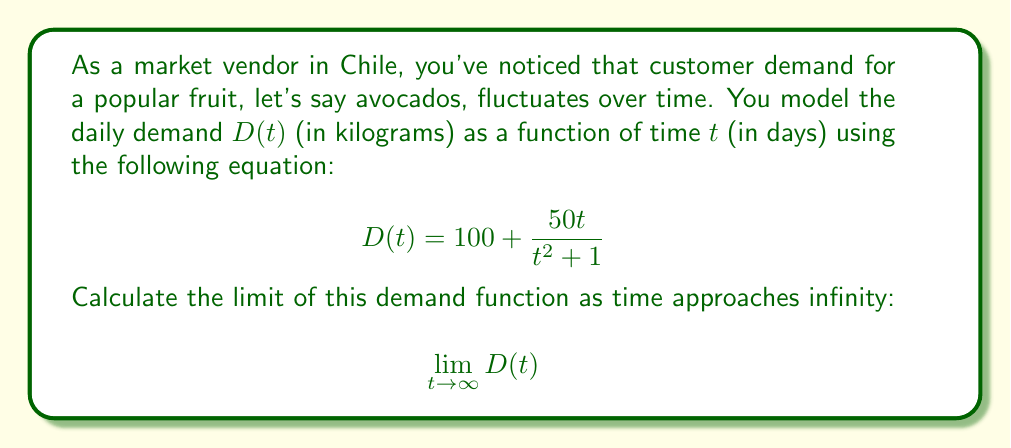Could you help me with this problem? To solve this problem, let's follow these steps:

1) First, let's recall the limit definition:
   $$\lim_{t \to \infty} D(t) = \lim_{t \to \infty} \left(100 + \frac{50t}{t^2 + 1}\right)$$

2) We can split this limit into two parts:
   $$\lim_{t \to \infty} 100 + \lim_{t \to \infty} \frac{50t}{t^2 + 1}$$

3) The first part is simple: $\lim_{t \to \infty} 100 = 100$

4) For the second part, let's focus on $\frac{50t}{t^2 + 1}$. We can simplify this by dividing both numerator and denominator by $t^2$:
   $$\lim_{t \to \infty} \frac{50t}{t^2 + 1} = \lim_{t \to \infty} \frac{50/t}{1 + 1/t^2}$$

5) As $t$ approaches infinity:
   - $1/t^2$ approaches 0
   - $1/t$ also approaches 0

6) Therefore:
   $$\lim_{t \to \infty} \frac{50/t}{1 + 1/t^2} = \frac{0}{1 + 0} = 0$$

7) Combining the results from steps 3 and 6:
   $$\lim_{t \to \infty} D(t) = 100 + 0 = 100$$

This result suggests that as time goes on, the daily demand for avocados will stabilize around 100 kilograms per day.
Answer: $$\lim_{t \to \infty} D(t) = 100$$ 